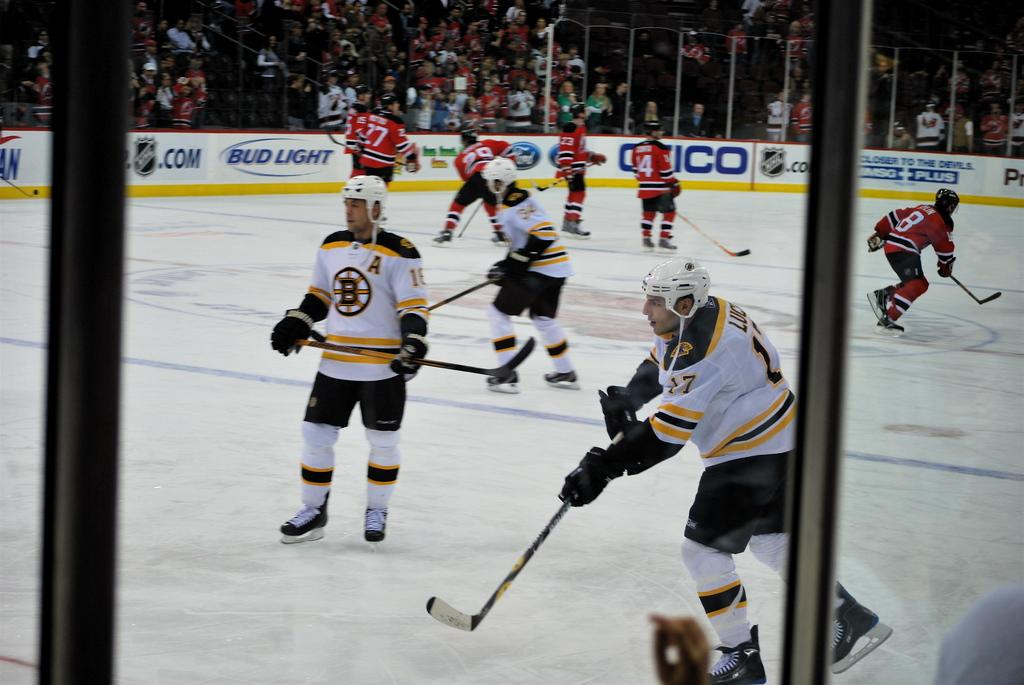What sport are the people in the image playing? The people in the image are playing ice hockey. What protective gear are the players wearing? The people playing ice hockey are wearing helmets and gloves. What type of footwear are the players wearing? The people playing ice hockey are wearing shoes. Can you describe the people in the background of the image? There are people in the background of the image, but their specific actions or appearance are not clear from the provided facts. What type of advertisements or signs can be seen in the background of the image? There are hoardings visible in the background of the image. How does the laborer use the calculator to tie a knot in the image? There is no laborer, calculator, or knot present in the image. 